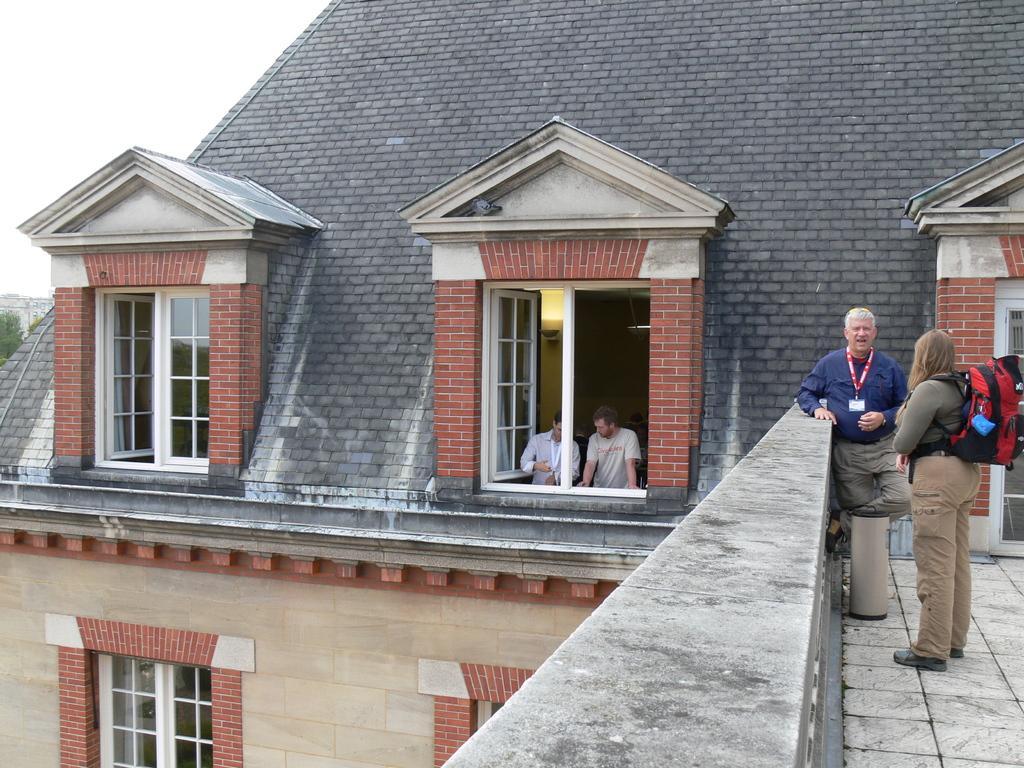In one or two sentences, can you explain what this image depicts? On the right side a woman is standing and also wearing a bag, here a man is standing near the wall, he wore blue color shirt. This is the building and these are the windows on the left side there is a sky. 